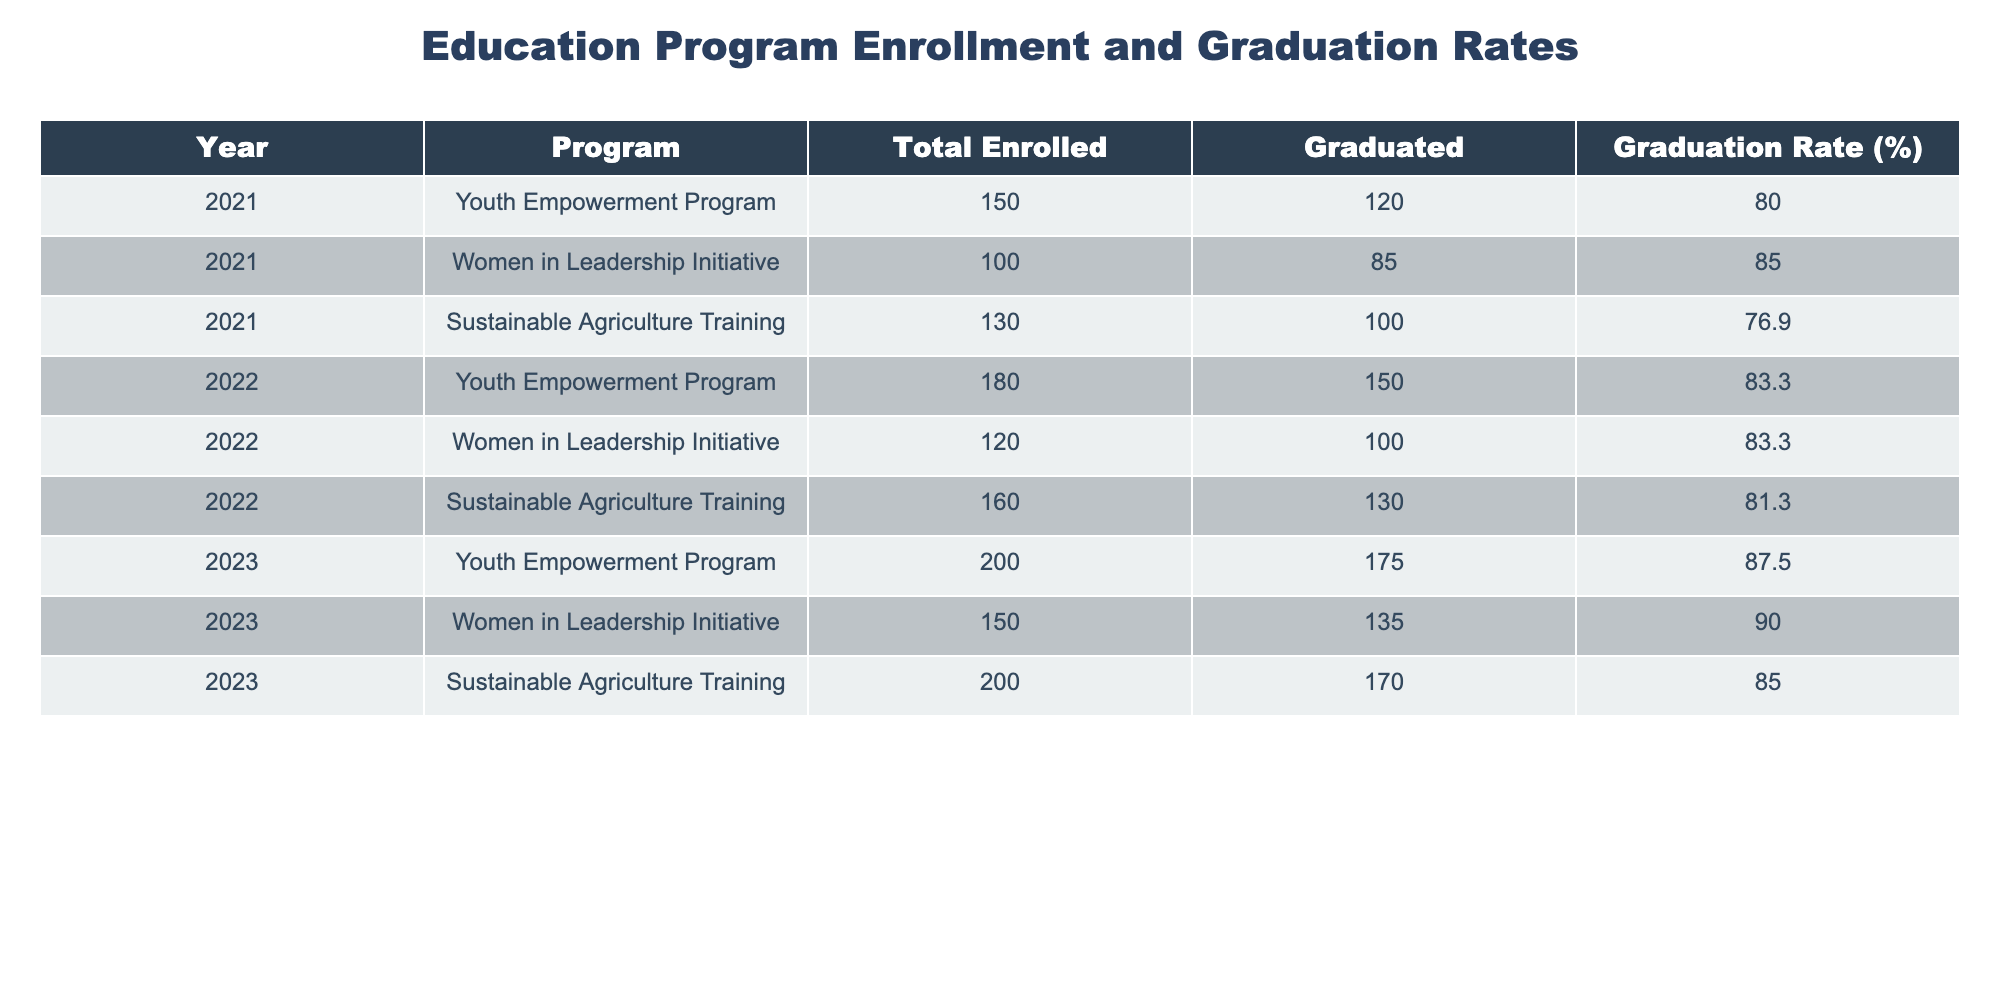What was the graduation rate for the Women in Leadership Initiative in 2022? The table shows that the graduation rate for the Women in Leadership Initiative in 2022 is 83.3%.
Answer: 83.3% Which program had the highest total enrollment in 2023? Looking at the total enrolled column for 2023, the Youth Empowerment Program and Sustainable Agriculture Training both had 200. However, the Sustainable Agriculture Training has a higher graduation count, but the question is solely about enrollment.
Answer: Youth Empowerment Program What was the total number of graduates across all programs in 2021? Adding the number of graduates for all programs in 2021: 120 (Youth Empowerment) + 85 (Women in Leadership) + 100 (Sustainable Agriculture) = 305.
Answer: 305 Was the graduation rate for the Sustainable Agriculture Training program ever higher than 80%? Checking the graduation rates from the table, Sustainable Agriculture Training had rates of 76.9% in 2021, 81.3% in 2022, and 85.0% in 2023. Since 2022 is the first instance above 80%, the answer is yes.
Answer: Yes What is the average graduation rate across all programs in 2023? The graduation rates for 2023 are 87.5% (Youth Empowerment), 90.0% (Women in Leadership), and 85.0% (Sustainable Agriculture). Adding these gives 262.5%, and dividing by 3 gives an average of 87.5%.
Answer: 87.5% Which year saw the largest increase in enrollment across programs compared to the previous year? Comparing the total enrolled numbers: 2021 had 380 total (150+100+130), 2022 saw an increase to 460 (180+120+160), and 2023 had 550 (200+150+200). The biggest increase was from 2022 to 2023, which was 90.
Answer: From 2022 to 2023 What was the percentage increase in graduates from the Youth Empowerment Program from 2021 to 2023? Graduates increased from 120 in 2021 to 175 in 2023. The difference is 55 graduates. The percentage increase is calculated as (55/120) * 100 = 45.83%.
Answer: 45.83% Is there a trend in graduation rates for the Women in Leadership Initiative over the three years? The graduation rates for the Women in Leadership Initiative were 85.0% in 2021, 83.3% in 2022, and 90.0% in 2023. This indicates an increase overall, especially from 2022 to 2023, suggesting a positive trend.
Answer: Yes What is the total enrollment for all programs in 2022? Summing the total enrolled for all programs in 2022: 180 (Youth Empowerment) + 120 (Women in Leadership) + 160 (Sustainable Agriculture) = 460.
Answer: 460 Did any program maintain the same graduation rate from one year to the next? Checking the data shows that no program had the same graduation rate from one year to the next; all rates changed year-over-year.
Answer: No 